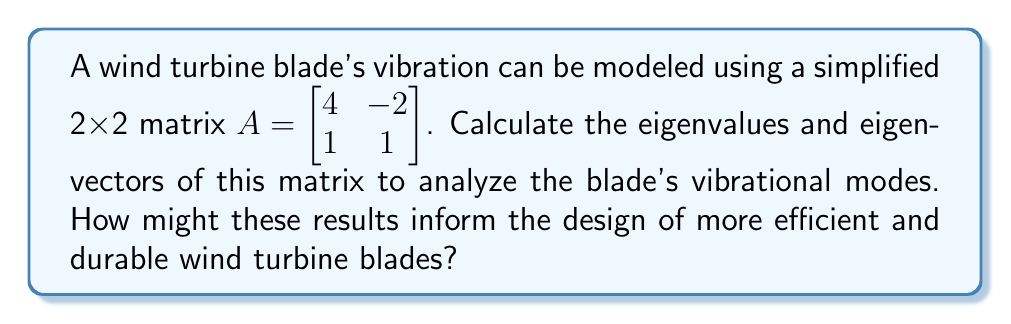What is the answer to this math problem? To find the eigenvalues and eigenvectors of matrix $A$:

1. Calculate the characteristic equation:
   $$det(A - \lambda I) = \begin{vmatrix} 4-\lambda & -2 \\ 1 & 1-\lambda \end{vmatrix} = 0$$
   $$(4-\lambda)(1-\lambda) + 2 = 0$$
   $$\lambda^2 - 5\lambda + 6 = 0$$

2. Solve for eigenvalues:
   Using the quadratic formula: $\lambda = \frac{5 \pm \sqrt{25 - 24}}{2}$
   $$\lambda_1 = 3, \lambda_2 = 2$$

3. Find eigenvectors for $\lambda_1 = 3$:
   $$(A - 3I)\vec{v} = \vec{0}$$
   $$\begin{bmatrix} 1 & -2 \\ 1 & -2 \end{bmatrix}\begin{bmatrix} v_1 \\ v_2 \end{bmatrix} = \begin{bmatrix} 0 \\ 0 \end{bmatrix}$$
   $$v_1 - 2v_2 = 0$$
   $$v_1 = 2v_2$$
   Eigenvector: $\vec{v}_1 = \begin{bmatrix} 2 \\ 1 \end{bmatrix}$

4. Find eigenvectors for $\lambda_2 = 2$:
   $$(A - 2I)\vec{v} = \vec{0}$$
   $$\begin{bmatrix} 2 & -2 \\ 1 & -1 \end{bmatrix}\begin{bmatrix} v_1 \\ v_2 \end{bmatrix} = \begin{bmatrix} 0 \\ 0 \end{bmatrix}$$
   $$2v_1 - 2v_2 = 0$$
   $$v_1 = v_2$$
   Eigenvector: $\vec{v}_2 = \begin{bmatrix} 1 \\ 1 \end{bmatrix}$

These results inform wind turbine blade design by:
1. Eigenvalues (3 and 2) represent the natural frequencies of vibration.
2. Eigenvectors show the corresponding mode shapes.
3. Higher eigenvalues indicate stiffer structures, potentially reducing fatigue.
4. Designers can optimize blade shape and material to avoid resonance with operational frequencies.
5. Understanding these modes helps in developing more efficient damping systems.
Answer: Eigenvalues: $\lambda_1 = 3, \lambda_2 = 2$
Eigenvectors: $\vec{v}_1 = \begin{bmatrix} 2 \\ 1 \end{bmatrix}, \vec{v}_2 = \begin{bmatrix} 1 \\ 1 \end{bmatrix}$ 